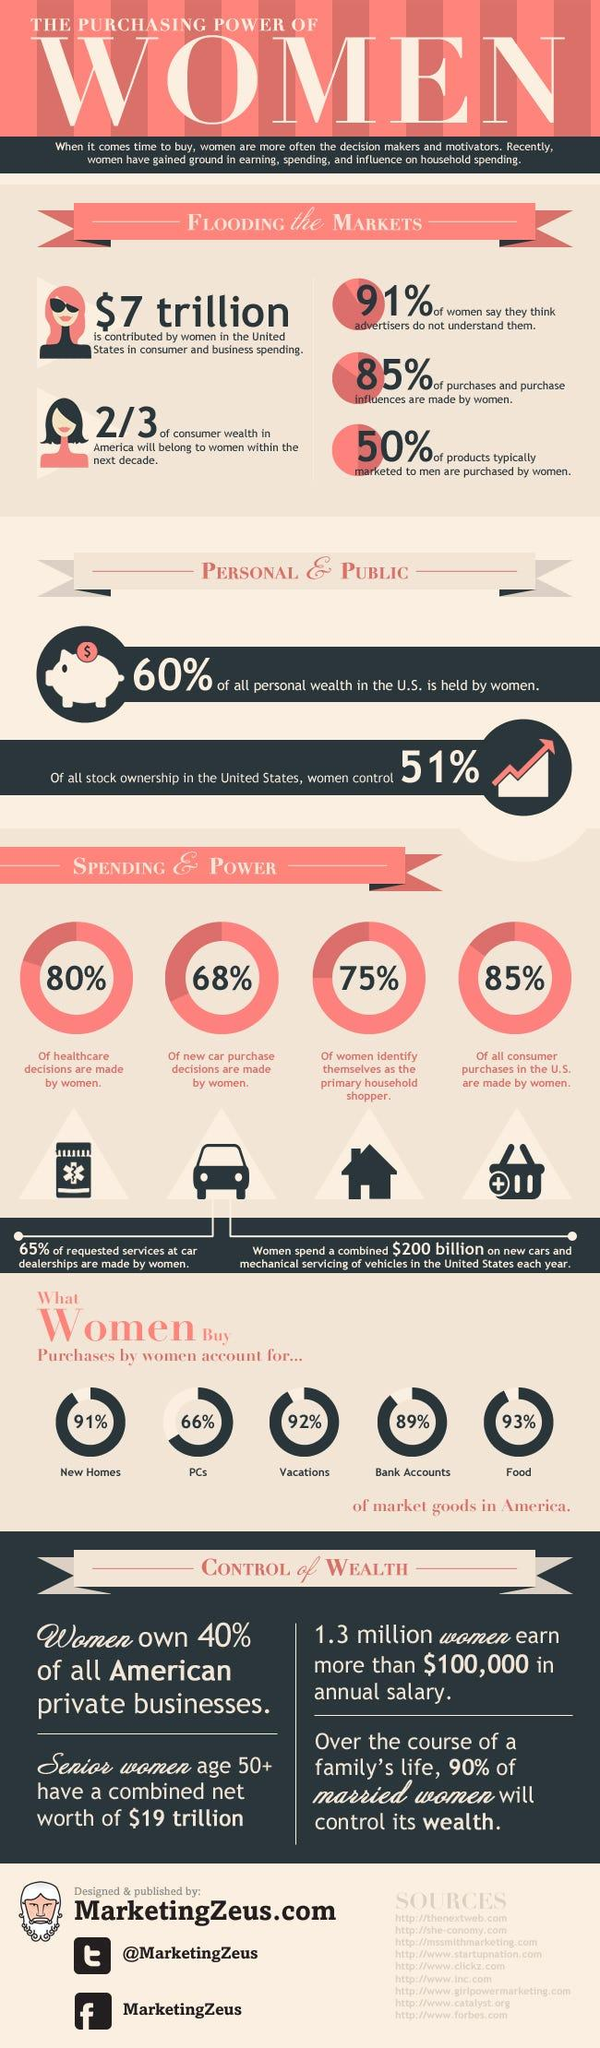Draw attention to some important aspects in this diagram. According to data, 40% of private businesses in the US are owned by women. A recent survey found that 91% of women believe that advertisers misunderstand them. According to a recent study, 68% of new car purchasing decisions are made by women. It is expected that married women will have a higher level of control over money in families in the future. Each year, women in the US spend approximately $200 billion on the servicing and purchase of vehicles. 